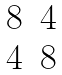Convert formula to latex. <formula><loc_0><loc_0><loc_500><loc_500>\begin{matrix} 8 & 4 \\ 4 & 8 \end{matrix}</formula> 